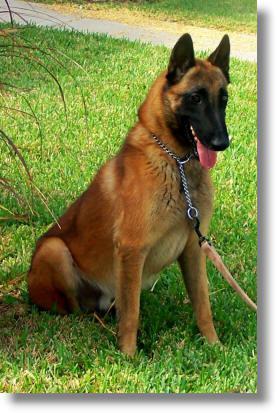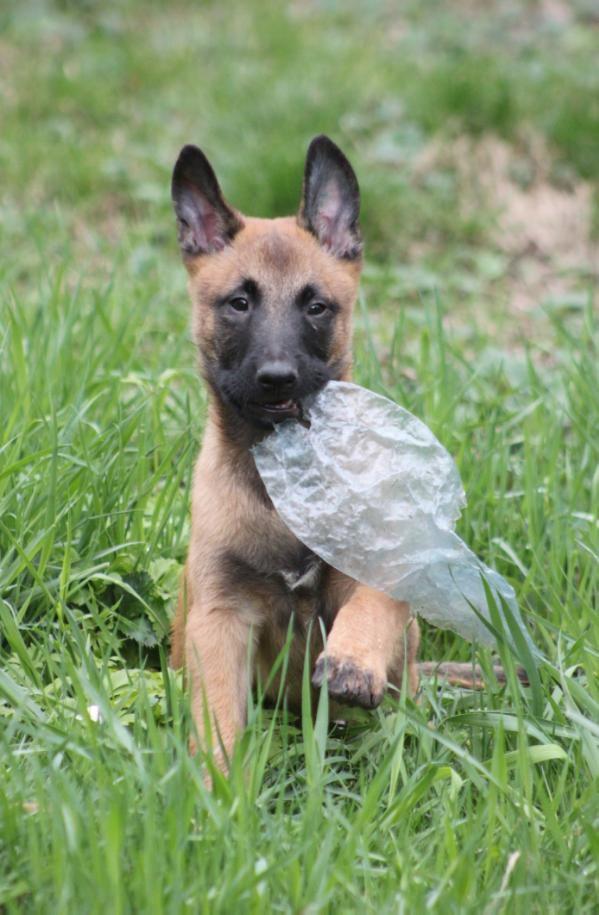The first image is the image on the left, the second image is the image on the right. Assess this claim about the two images: "the right image has a dog standing on all 4's with a taught leash". Correct or not? Answer yes or no. No. The first image is the image on the left, the second image is the image on the right. Examine the images to the left and right. Is the description "There is a total of 1 dog facing right is a grassy area." accurate? Answer yes or no. Yes. 